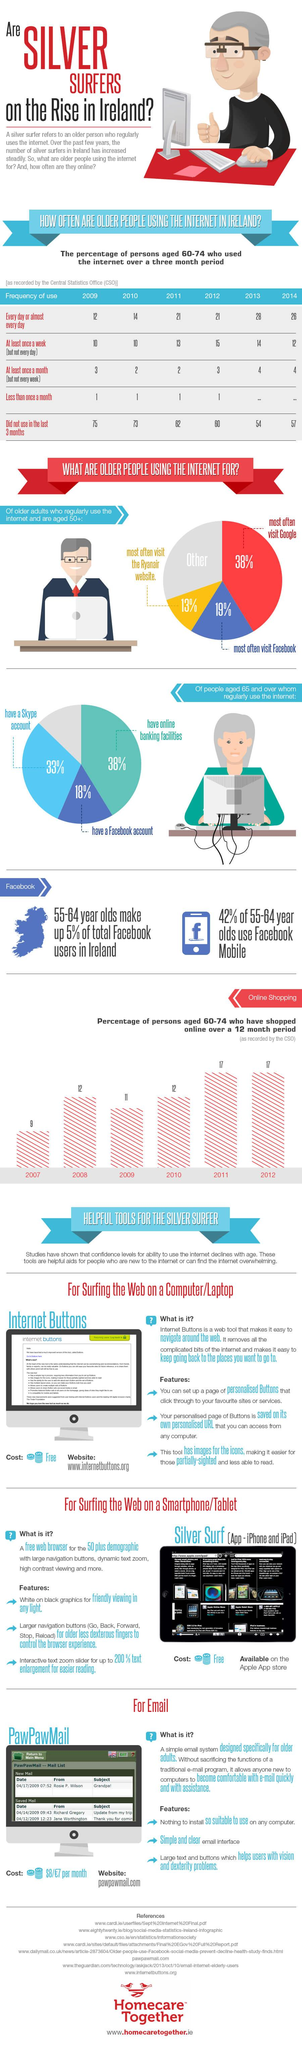Mention a couple of crucial points in this snapshot. The tools that are easy for the "silver surfer" to use when using a computer/laptop, smartphone/tablet, or email are Internet Buttons, Silver Surf, and PawPawMail. According to a recent survey, 57% of people use the internet for Facebook and Google. In the years 2008, 2010, and possibly other years, 12% of persons aged 60-74 have shopped online. The number of daily silver surfer users has increased significantly from 2009 to 2014. In the years 2011, 2012, and possibly other years, the percentage of individuals aged 60-74 who have shopped online was 17. 